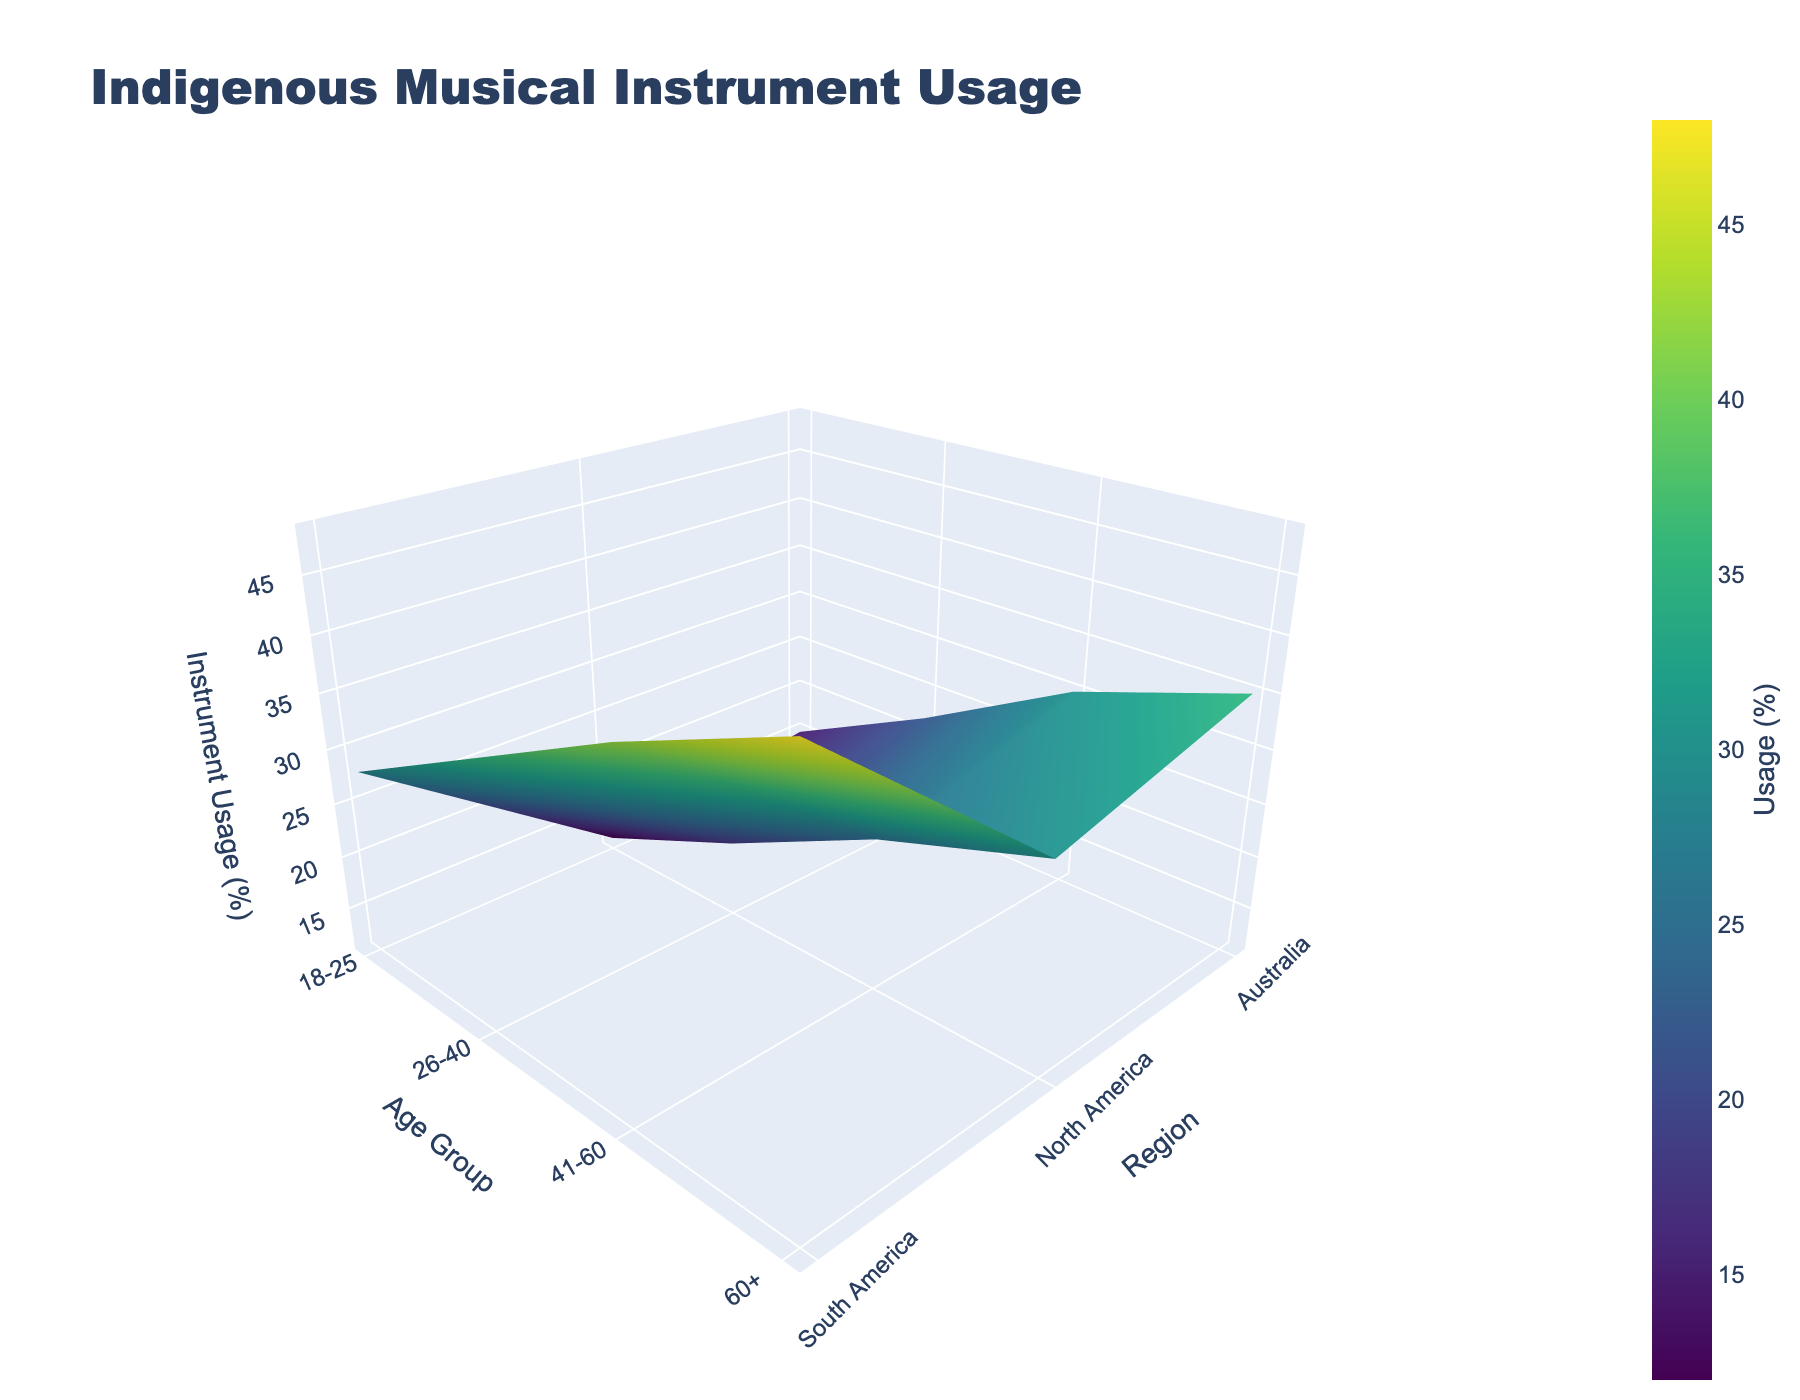What is the title of the figure? The title is located at the top of the figure.
Answer: Indigenous Musical Instrument Usage Which region shows the highest instrument usage for the 60+ age group? The highest instrument usage for the 60+ age group can be identified by looking at the peak values on the z-axis for the 60+ age group grid section.
Answer: South America How does the instrument usage in North America for the 41-60 age group compare to that in Australia for the same age group? Look at the z-values for the 41-60 age group in both North American and Australian regions. It shows 25% for North America and 30% for Australia.
Answer: North America has lower usage than Australia What is the color used for regions with the highest instrument usage percentage? The color for the highest instrument usage is part of the "Viridis" color scale used in the plot and is usually the brightest, such as yellow.
Answer: Yellow What is the overall trend in instrument usage among different age groups in South America? Check the heights and colors of the surface for South America across all age groups. They increase from about 28% (18-25) to 48% (60+).
Answer: Increasing trend What is the average instrument usage percentage across all regions for the 26-40 age group? Identify the z-values for the 26-40 age group in all regions: 18% (North America), 35% (South America), and 22% (Australia). Calculate the average: (18 + 35 + 22) / 3 = 25%.
Answer: 25% Which age group has the most uniform distribution of instrument usage across all regions? Evaluate the z-values for each age group across all regions to find where the differences are minimal. The 18-25 group has values relatively close: 12%, 28%, and 15%.
Answer: 18-25 Is the instrument usage higher in Australia or North America for the 60+ age group? Compare the z-values in the 60+ section: Australia has 35% and North America has 30%.
Answer: Australia What is the difference in instrument usage between the youngest and oldest age groups in South America? Subtract the instrument usage percentage for 18-25 age group from that of the 60+ age group in South America: 48% - 28% = 20%.
Answer: 20% Looking at the plot, which age group sees the steepest increase in instrument usage moving from North America to South America? Compare the slopes of the surfaces for each age group between North America and South America. The 60+ age group shows the steepest increase from 30% to 48%, a rise of 18%.
Answer: 60+ 